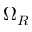Convert formula to latex. <formula><loc_0><loc_0><loc_500><loc_500>\Omega _ { R }</formula> 